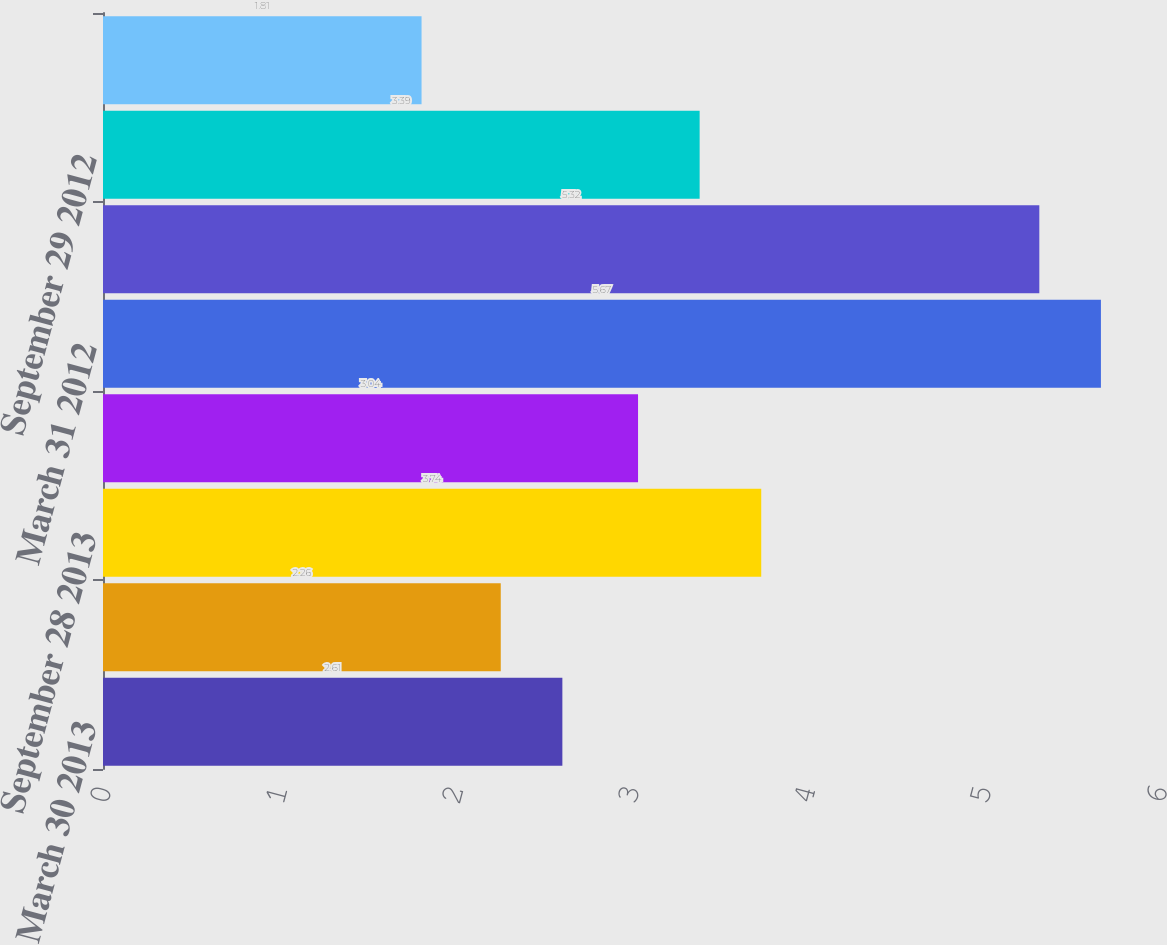Convert chart to OTSL. <chart><loc_0><loc_0><loc_500><loc_500><bar_chart><fcel>March 30 2013<fcel>June 29 2013<fcel>September 28 2013<fcel>December 28 2013<fcel>March 31 2012<fcel>June 30 2012<fcel>September 29 2012<fcel>December 29 2012<nl><fcel>2.61<fcel>2.26<fcel>3.74<fcel>3.04<fcel>5.67<fcel>5.32<fcel>3.39<fcel>1.81<nl></chart> 